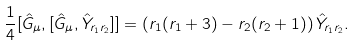Convert formula to latex. <formula><loc_0><loc_0><loc_500><loc_500>\frac { 1 } { 4 } [ \hat { G } _ { \mu } , [ \hat { G } _ { \mu } , \hat { Y } _ { r _ { 1 } r _ { 2 } } ] ] = \left ( r _ { 1 } ( r _ { 1 } + 3 ) - r _ { 2 } ( r _ { 2 } + 1 ) \right ) \hat { Y } _ { r _ { 1 } r _ { 2 } } .</formula> 